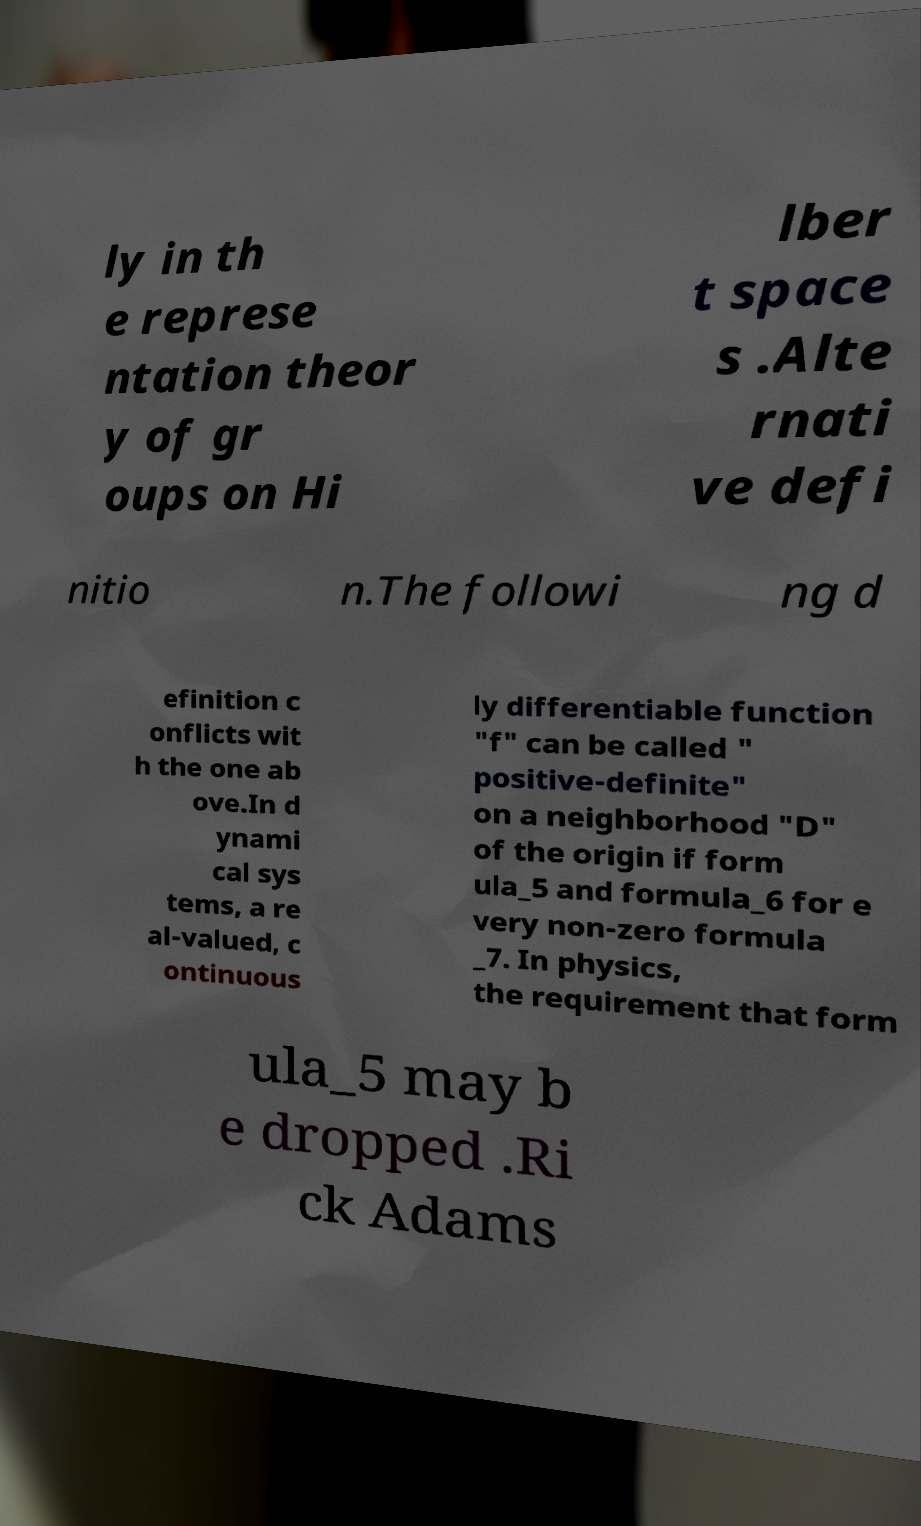I need the written content from this picture converted into text. Can you do that? ly in th e represe ntation theor y of gr oups on Hi lber t space s .Alte rnati ve defi nitio n.The followi ng d efinition c onflicts wit h the one ab ove.In d ynami cal sys tems, a re al-valued, c ontinuous ly differentiable function "f" can be called " positive-definite" on a neighborhood "D" of the origin if form ula_5 and formula_6 for e very non-zero formula _7. In physics, the requirement that form ula_5 may b e dropped .Ri ck Adams 